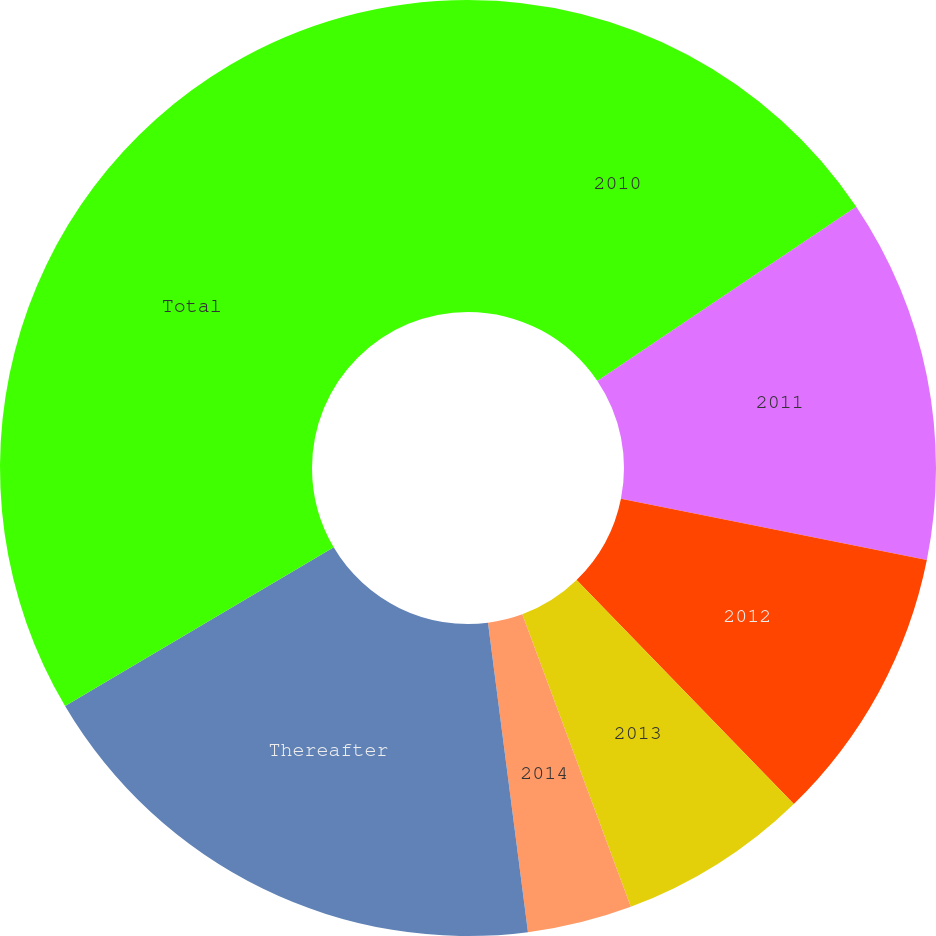<chart> <loc_0><loc_0><loc_500><loc_500><pie_chart><fcel>2010<fcel>2011<fcel>2012<fcel>2013<fcel>2014<fcel>Thereafter<fcel>Total<nl><fcel>15.57%<fcel>12.58%<fcel>9.59%<fcel>6.6%<fcel>3.61%<fcel>18.55%<fcel>33.49%<nl></chart> 